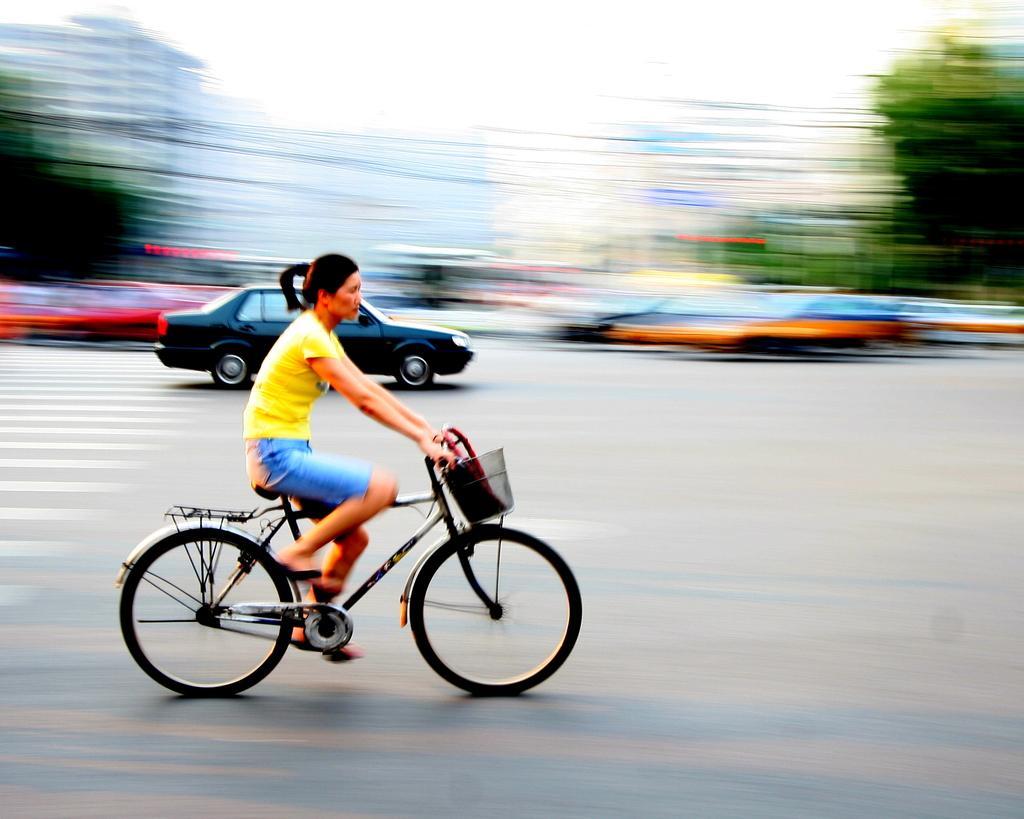Can you describe this image briefly? Background of the picture is very blurry. Here we can see few vehicles on the road and one women is riding a bicycle. She wore yellow color t shirt and a blue colour short. 